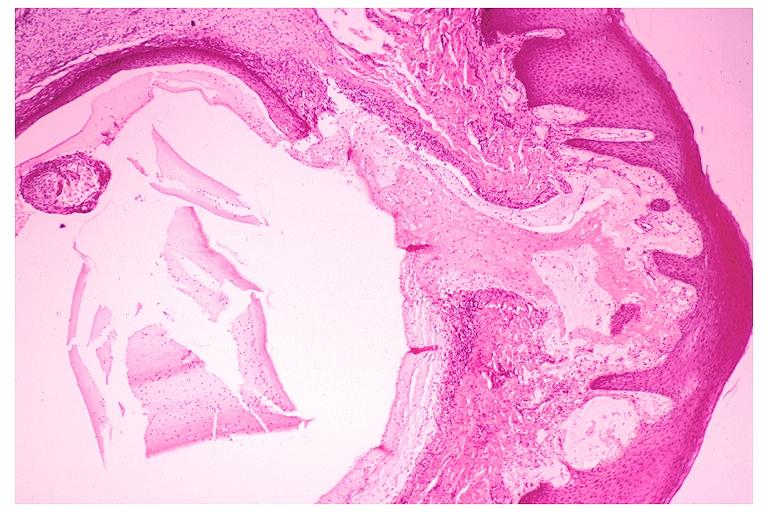what does this image show?
Answer the question using a single word or phrase. Mucocele 